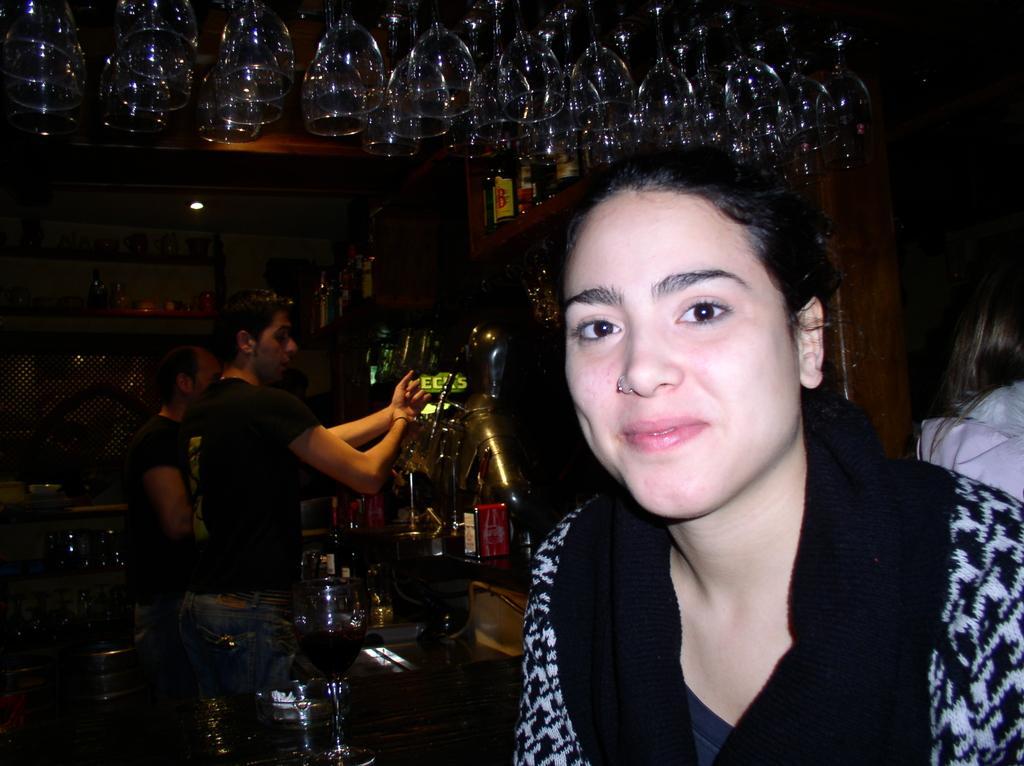Describe this image in one or two sentences. In this picture there is a woman wearing black and white dress is in the right corner and there are few glasses above her and there are two persons and some other objects in the background. 